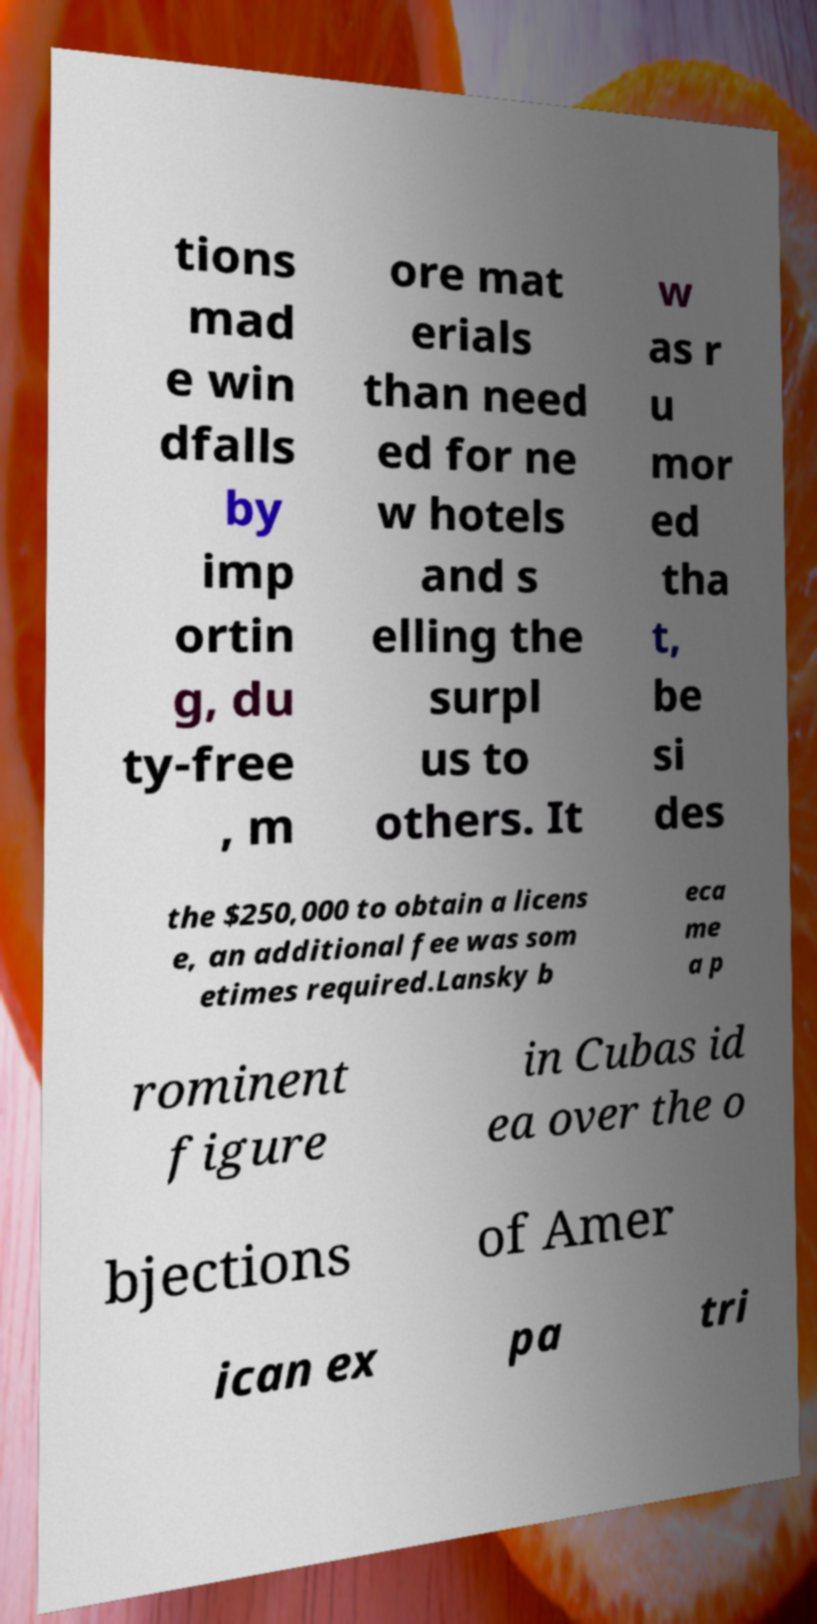For documentation purposes, I need the text within this image transcribed. Could you provide that? tions mad e win dfalls by imp ortin g, du ty-free , m ore mat erials than need ed for ne w hotels and s elling the surpl us to others. It w as r u mor ed tha t, be si des the $250,000 to obtain a licens e, an additional fee was som etimes required.Lansky b eca me a p rominent figure in Cubas id ea over the o bjections of Amer ican ex pa tri 